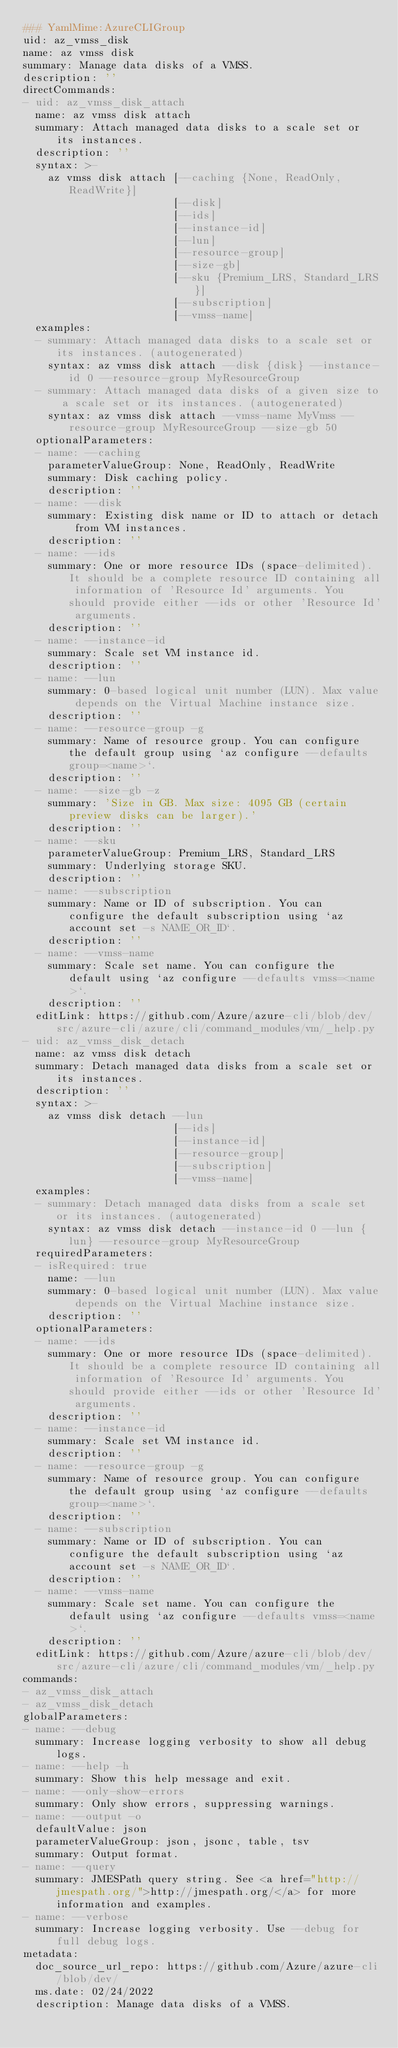<code> <loc_0><loc_0><loc_500><loc_500><_YAML_>### YamlMime:AzureCLIGroup
uid: az_vmss_disk
name: az vmss disk
summary: Manage data disks of a VMSS.
description: ''
directCommands:
- uid: az_vmss_disk_attach
  name: az vmss disk attach
  summary: Attach managed data disks to a scale set or its instances.
  description: ''
  syntax: >-
    az vmss disk attach [--caching {None, ReadOnly, ReadWrite}]
                        [--disk]
                        [--ids]
                        [--instance-id]
                        [--lun]
                        [--resource-group]
                        [--size-gb]
                        [--sku {Premium_LRS, Standard_LRS}]
                        [--subscription]
                        [--vmss-name]
  examples:
  - summary: Attach managed data disks to a scale set or its instances. (autogenerated)
    syntax: az vmss disk attach --disk {disk} --instance-id 0 --resource-group MyResourceGroup
  - summary: Attach managed data disks of a given size to a scale set or its instances. (autogenerated)
    syntax: az vmss disk attach --vmss-name MyVmss --resource-group MyResourceGroup --size-gb 50
  optionalParameters:
  - name: --caching
    parameterValueGroup: None, ReadOnly, ReadWrite
    summary: Disk caching policy.
    description: ''
  - name: --disk
    summary: Existing disk name or ID to attach or detach from VM instances.
    description: ''
  - name: --ids
    summary: One or more resource IDs (space-delimited). It should be a complete resource ID containing all information of 'Resource Id' arguments. You should provide either --ids or other 'Resource Id' arguments.
    description: ''
  - name: --instance-id
    summary: Scale set VM instance id.
    description: ''
  - name: --lun
    summary: 0-based logical unit number (LUN). Max value depends on the Virtual Machine instance size.
    description: ''
  - name: --resource-group -g
    summary: Name of resource group. You can configure the default group using `az configure --defaults group=<name>`.
    description: ''
  - name: --size-gb -z
    summary: 'Size in GB. Max size: 4095 GB (certain preview disks can be larger).'
    description: ''
  - name: --sku
    parameterValueGroup: Premium_LRS, Standard_LRS
    summary: Underlying storage SKU.
    description: ''
  - name: --subscription
    summary: Name or ID of subscription. You can configure the default subscription using `az account set -s NAME_OR_ID`.
    description: ''
  - name: --vmss-name
    summary: Scale set name. You can configure the default using `az configure --defaults vmss=<name>`.
    description: ''
  editLink: https://github.com/Azure/azure-cli/blob/dev/src/azure-cli/azure/cli/command_modules/vm/_help.py
- uid: az_vmss_disk_detach
  name: az vmss disk detach
  summary: Detach managed data disks from a scale set or its instances.
  description: ''
  syntax: >-
    az vmss disk detach --lun
                        [--ids]
                        [--instance-id]
                        [--resource-group]
                        [--subscription]
                        [--vmss-name]
  examples:
  - summary: Detach managed data disks from a scale set or its instances. (autogenerated)
    syntax: az vmss disk detach --instance-id 0 --lun {lun} --resource-group MyResourceGroup
  requiredParameters:
  - isRequired: true
    name: --lun
    summary: 0-based logical unit number (LUN). Max value depends on the Virtual Machine instance size.
    description: ''
  optionalParameters:
  - name: --ids
    summary: One or more resource IDs (space-delimited). It should be a complete resource ID containing all information of 'Resource Id' arguments. You should provide either --ids or other 'Resource Id' arguments.
    description: ''
  - name: --instance-id
    summary: Scale set VM instance id.
    description: ''
  - name: --resource-group -g
    summary: Name of resource group. You can configure the default group using `az configure --defaults group=<name>`.
    description: ''
  - name: --subscription
    summary: Name or ID of subscription. You can configure the default subscription using `az account set -s NAME_OR_ID`.
    description: ''
  - name: --vmss-name
    summary: Scale set name. You can configure the default using `az configure --defaults vmss=<name>`.
    description: ''
  editLink: https://github.com/Azure/azure-cli/blob/dev/src/azure-cli/azure/cli/command_modules/vm/_help.py
commands:
- az_vmss_disk_attach
- az_vmss_disk_detach
globalParameters:
- name: --debug
  summary: Increase logging verbosity to show all debug logs.
- name: --help -h
  summary: Show this help message and exit.
- name: --only-show-errors
  summary: Only show errors, suppressing warnings.
- name: --output -o
  defaultValue: json
  parameterValueGroup: json, jsonc, table, tsv
  summary: Output format.
- name: --query
  summary: JMESPath query string. See <a href="http://jmespath.org/">http://jmespath.org/</a> for more information and examples.
- name: --verbose
  summary: Increase logging verbosity. Use --debug for full debug logs.
metadata:
  doc_source_url_repo: https://github.com/Azure/azure-cli/blob/dev/
  ms.date: 02/24/2022
  description: Manage data disks of a VMSS.
</code> 